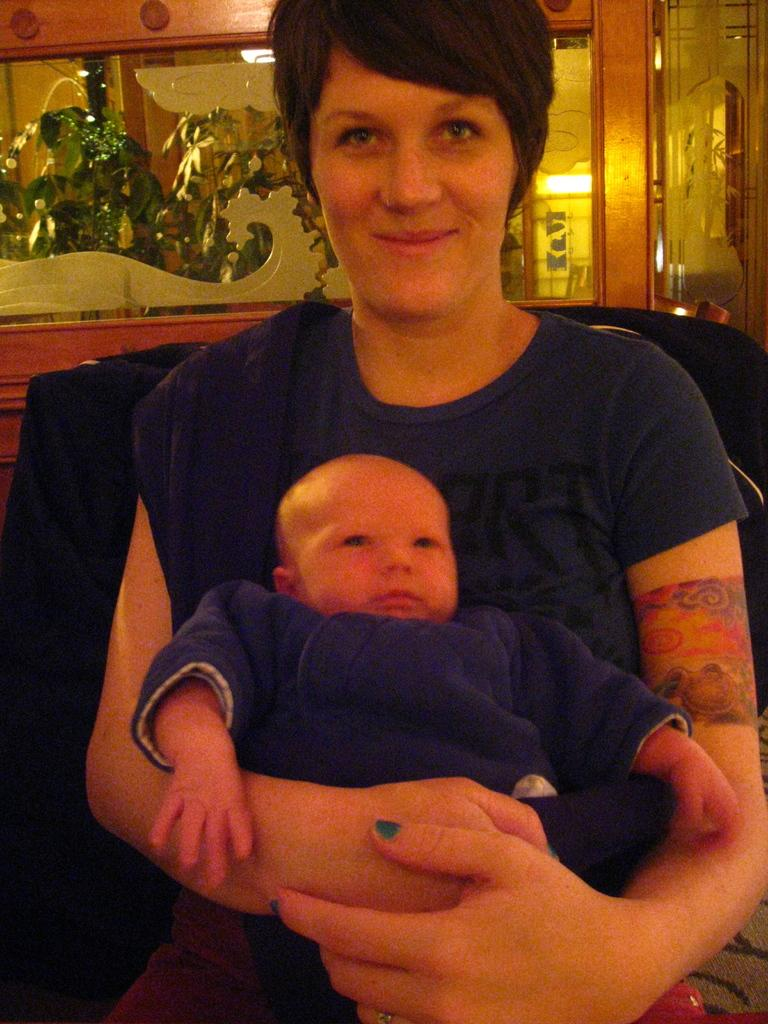Who is the main subject in the image? There is a lady sitting in the center of the image. What is the lady doing in the image? The lady is holding a baby. What can be seen in the background of the image? There is a door, glass, and a plant in the background of the image. What type of square object can be seen in the image? There is no square object present in the image. What can be seen through the glass in the image? The image does not show a view through the glass, as it is only mentioned as being present in the background. 